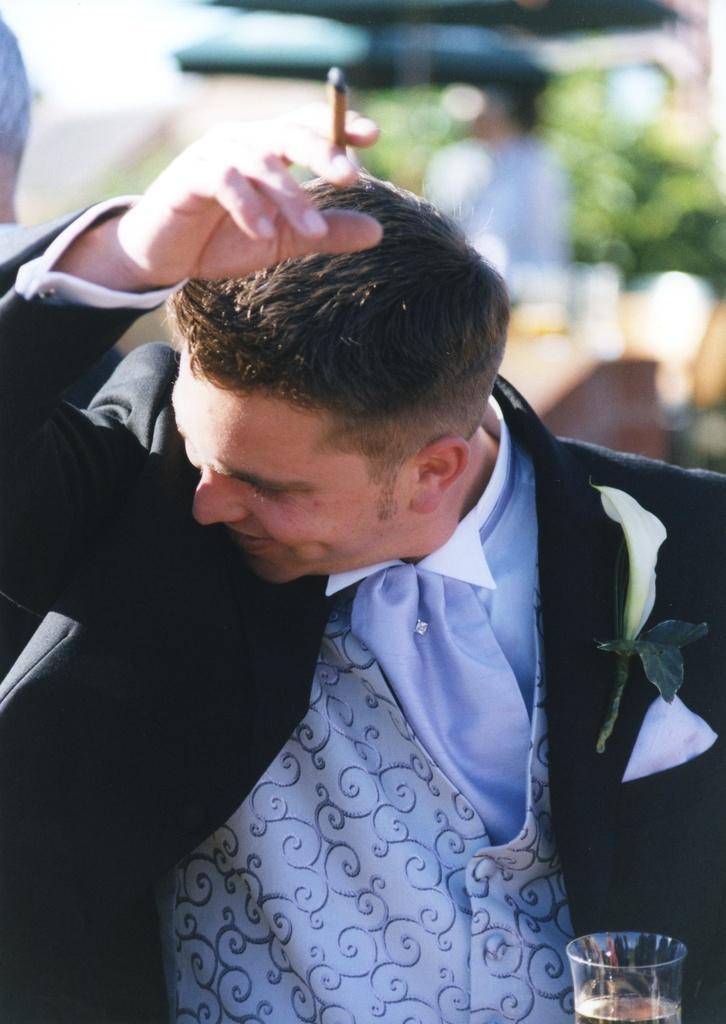Can you describe this image briefly? In this image, in the middle, we can see a man wearing a black color coat and holding a cigar on one hand and a glass on the other hand. In the background, we can see a group of people and green color. 